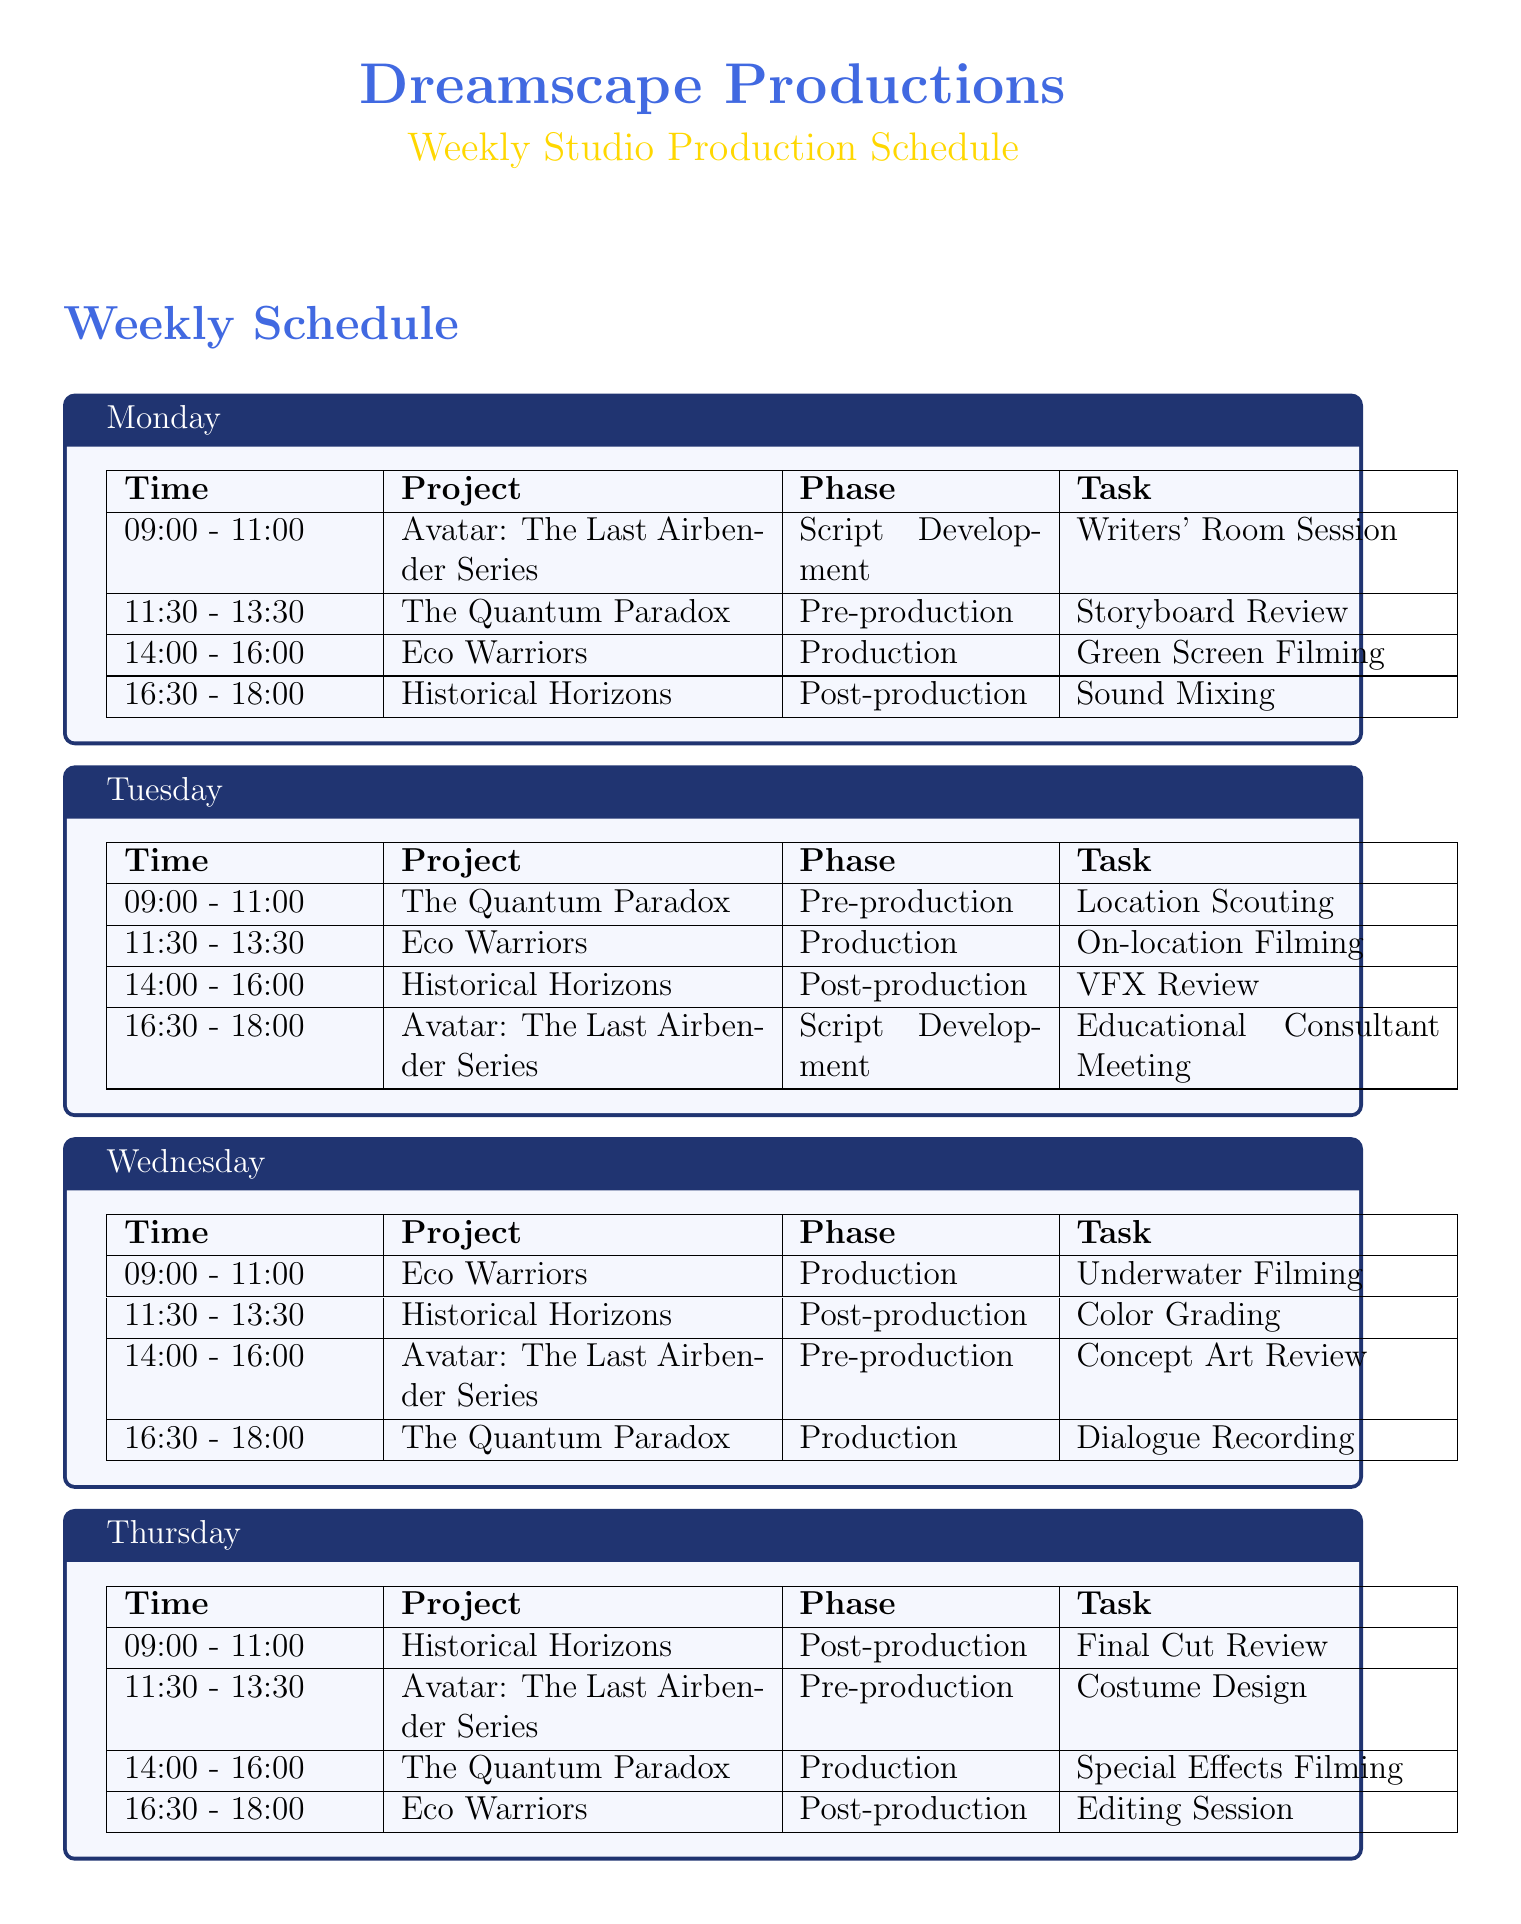What project is scheduled for 14:00 - 16:00 on Monday? The project scheduled during this time is listed in the time slot for Monday in the schedule.
Answer: Eco Warriors What task is planned for Historical Horizons on Thursday? The specific task for Historical Horizons can be found in the Thursday section of the schedule.
Answer: Final Cut Review How many projects are being handled throughout the week? The total number of distinct projects can be counted based on the unique project titles listed in the schedule.
Answer: Four What is the primary phase of The Quantum Paradox on Tuesday? This information is contained in the time slot for The Quantum Paradox on Tuesday, indicating what phase the project is in.
Answer: Pre-production Which day has underwater filming scheduled? This task can be identified by looking at the scheduled tasks for each day, noting what project is assigned underwater filming.
Answer: Wednesday What educational element is associated with Eco Warriors? The educational elements are specifically mentioned under the Eco Warriors section in the schedule.
Answer: Environmental conservation What is the last task on Friday? The last task of the day can be found in the Friday section detailing the sequence of tasks for that day.
Answer: Trailer Editing Which project includes a costume design task? This information is listed under the specific time slot for costume design in the schedule for that particular day.
Answer: Avatar: The Last Airbender Series What time does the educational consultant meeting take place? The time slot for this task can be found in the Tuesday schedule.
Answer: 16:30 - 18:00 